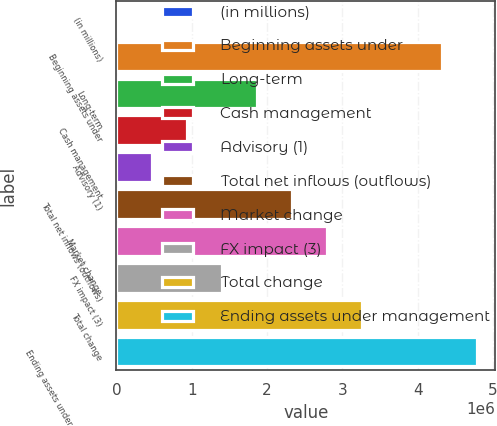Convert chart to OTSL. <chart><loc_0><loc_0><loc_500><loc_500><bar_chart><fcel>(in millions)<fcel>Beginning assets under<fcel>Long-term<fcel>Cash management<fcel>Advisory (1)<fcel>Total net inflows (outflows)<fcel>Market change<fcel>FX impact (3)<fcel>Total change<fcel>Ending assets under management<nl><fcel>2014<fcel>4.32409e+06<fcel>1.86197e+06<fcel>931990<fcel>467002<fcel>2.32695e+06<fcel>2.79194e+06<fcel>1.39698e+06<fcel>3.25693e+06<fcel>4.78908e+06<nl></chart> 